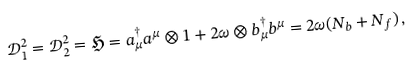Convert formula to latex. <formula><loc_0><loc_0><loc_500><loc_500>\mathcal { D } _ { 1 } ^ { 2 } = \mathcal { D } _ { 2 } ^ { 2 } = \mathfrak { H } = a _ { \mu } ^ { \dag } a ^ { \mu } \otimes 1 + 2 \omega \otimes b _ { \mu } ^ { \dag } b ^ { \mu } = 2 \omega ( N _ { b } + N _ { f } ) \, ,</formula> 